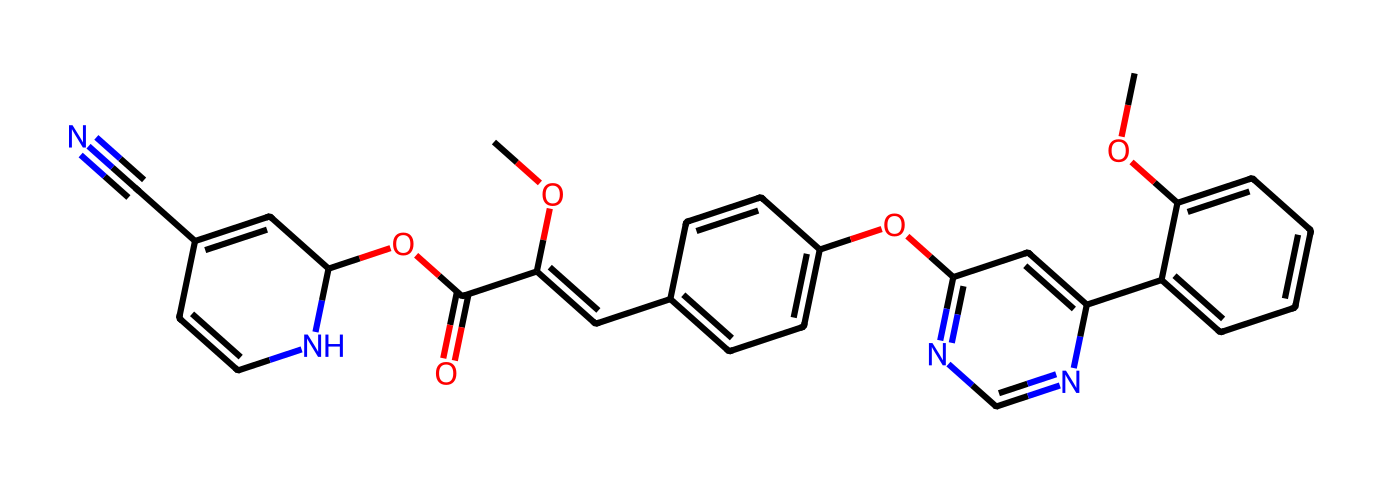What is the IUPAC name of this chemical? According to the SMILES representation, the compound's systematic name can be determined to be "2-[2-(6-methoxy-4-pyrimidinyl)-1-(phenoxymethyl)-1H-benzimidazol-2-yl]-N-methylbenzeneacetamide," indicating it is classified as azoxystrobin, a broad-spectrum fungicide.
Answer: azoxystrobin How many carbon atoms are present in the structure? By examining the SMILES representation and counting each 'C' or carbon segment, there are 22 carbon atoms in the structure of azoxystrobin.
Answer: 22 What type of functional groups are present in this structure? The SMILES notation indicates the presence of several functional groups, including esters (COC(=O)), ethers (the methoxy group), and a nitrile group (C#N), as evidenced by their characteristic notations in the SMILES.
Answer: ester, ether, nitrile How many rings are in the chemical structure? Analyzing the SMILES, the structure reveals there are three distinct ring systems (two aromatic rings and one heterocyclic ring), thus indicating the presence of multiple cyclic components in the molecule.
Answer: 3 What is the role of the nitrogen atom in this structure? The nitrogen in the pyrimidine ring could contribute to the reactivity of the molecule, conditioning the compound's effectiveness as a fungicide while impacting its physical properties, such as solubility and lipophilicity.
Answer: reactivity Is this compound considered a systemic fungicide? Azoxystrobin is recognized as a systemic fungicide, which means it is capable of being absorbed and translocated within the plant, providing broader protection against fungal diseases.
Answer: yes How does the presence of ester functional groups affect its properties? The ester functional groups are known to influence the solubility and bioavailability of compounds. In azoxystrobin, these groups contribute to the compound’s ability to interact with both hydrophilic and lipophilic environments, promoting its efficacy in agricultural applications.
Answer: increase solubility 